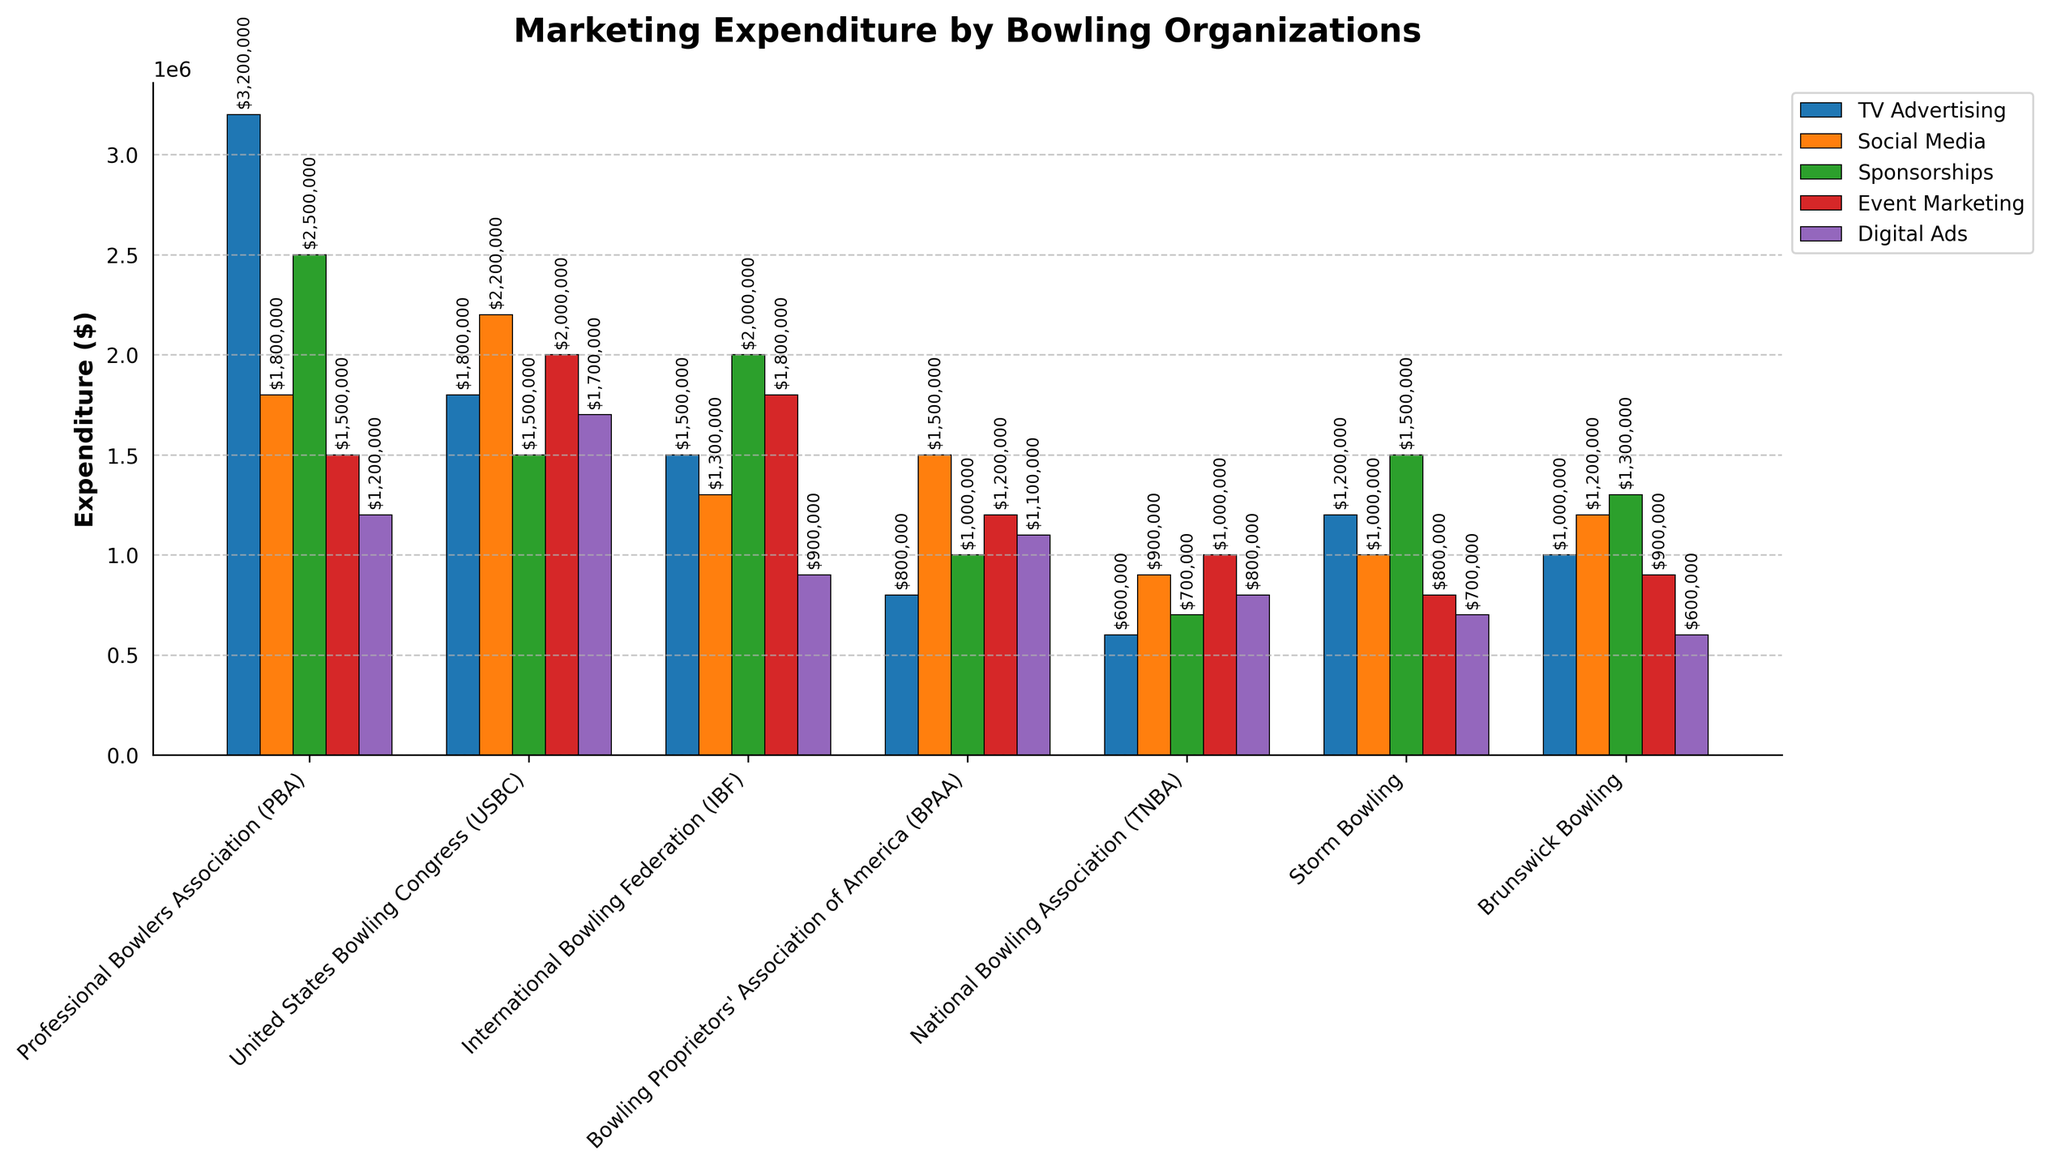What is the total marketing expenditure by the Professional Bowlers Association (PBA)? To calculate the total marketing expenditure by the PBA, sum the values for TV Advertising, Social Media, Sponsorships, Event Marketing, and Digital Ads from the bar chart. Specifically: $3,200,000 (TV Advertising) + $1,800,000 (Social Media) + $2,500,000 (Sponsorships) + $1,500,000 (Event Marketing) + $1,200,000 (Digital Ads) = $10,200,000.
Answer: $10,200,000 Which organization spends the most on Social Media marketing? Observe the height of the bars corresponding to Social Media marketing for each organization in the chart. The United States Bowling Congress (USBC) has the tallest bar for Social Media marketing spending $2,200,000.
Answer: USBC Which marketing channel does the International Bowling Federation (IBF) spend the least on? Compare the heights of the bars for each marketing channel within the IBF section. The shortest bar corresponds to Digital Ads, with an expenditure of $900,000.
Answer: Digital Ads What is the difference in TV Advertising expenditure between the highest and lowest spending organizations? Identify the highest and lowest bars for TV Advertising expenditure. The highest is the PBA with $3,200,000, and the lowest is TNBA with $600,000. Calculate the difference: $3,200,000 - $600,000 = $2,600,000.
Answer: $2,600,000 What is the average expenditure on Event Marketing across all organizations? Sum the expenditures on Event Marketing for all organizations and divide by the number of organizations. Specifically: ($1,500,000 (PBA) + $2,000,000 (USBC) + $1,800,000 (IBF) + $1,200,000 (BPAA) + $1,000,000 (TNBA) + $800,000 (Storm Bowling) + $900,000 (Brunswick Bowling)) / 7. Total is $9,200,000, thus average is $9,200,000 / 7 = $1,314,286 (rounded).
Answer: $1,314,286 Which organization allocates more budget towards Sponsorships, Storm Bowling or Brunswick Bowling? Compare the height of the bars representing Sponsorships expenditures for Storm Bowling and Brunswick Bowling. Storm Bowling spends $1,500,000, while Brunswick Bowling spends $1,300,000. Therefore, Storm Bowling allocates more.
Answer: Storm Bowling How much more does the Bowling Proprietors' Association of America (BPAA) spend on Digital Ads than Event Marketing? Identify the values for BPAA's expenditures on Digital Ads and Event Marketing bars. BPAA spends $1,100,000 on Digital Ads and $1,200,000 on Event Marketing. Calculate the difference: $1,200,000 - $1,100,000 = $100,000.
Answer: $100,000 Which marketing channel has the greatest variance in expenditure across organizations? Visually assess the bars for each marketing channel across all organizations to identify which one shows the largest range of heights. TV Advertising shows the greatest variance, ranging from $600,000 to $3,200,000.
Answer: TV Advertising 